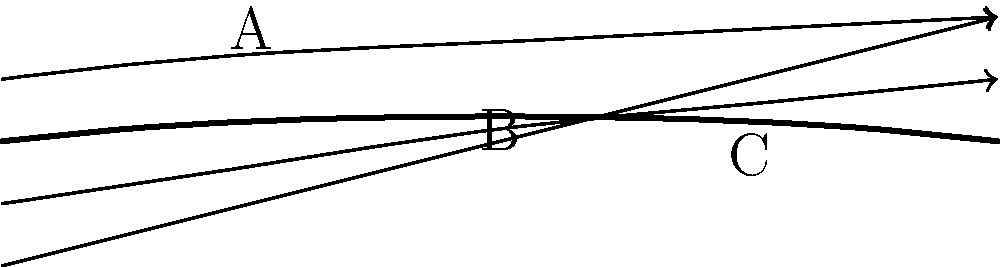As a former sculpture student influenced by Prof. Smith's teachings on form and flow, consider the airfoil shape and streamlines shown in the diagram. At which point (A, B, or C) would you expect the air pressure to be the lowest, and how might this relate to the principles of aerodynamic lift? To answer this question, let's break down the concepts step-by-step:

1. Airfoil shape: The diagram shows a typical airfoil profile, which is designed to create lift.

2. Bernoulli's principle: This principle states that as the speed of a fluid increases, its pressure decreases. This is crucial for understanding airflow around an airfoil.

3. Streamline analysis:
   - Streamlines represent the path of air particles.
   - The closer the streamlines, the faster the air moves.
   - The farther apart the streamlines, the slower the air moves.

4. Examining the points:
   - Point A: Streamlines are relatively far apart, indicating slower air movement.
   - Point B: Streamlines are closest together, indicating the fastest air movement.
   - Point C: Streamlines are beginning to spread out again, indicating slowing air movement.

5. Pressure distribution:
   - According to Bernoulli's principle, the point with the fastest air movement (closest streamlines) will have the lowest pressure.
   - Point B has the closest streamlines, so it will have the lowest pressure.

6. Relation to lift:
   - The pressure difference between the upper and lower surfaces of the airfoil creates lift.
   - The low pressure at point B (on the upper surface) contributes significantly to this pressure difference.

7. Sculptural perspective:
   - The airfoil shape can be seen as a carefully crafted form that interacts with its environment (air) to create a desired effect (lift).
   - This interaction between form and environment is reminiscent of sculptural principles, where the shape of an object influences how it's perceived and interacts with its surroundings.
Answer: Point B; lowest pressure due to highest air velocity. 